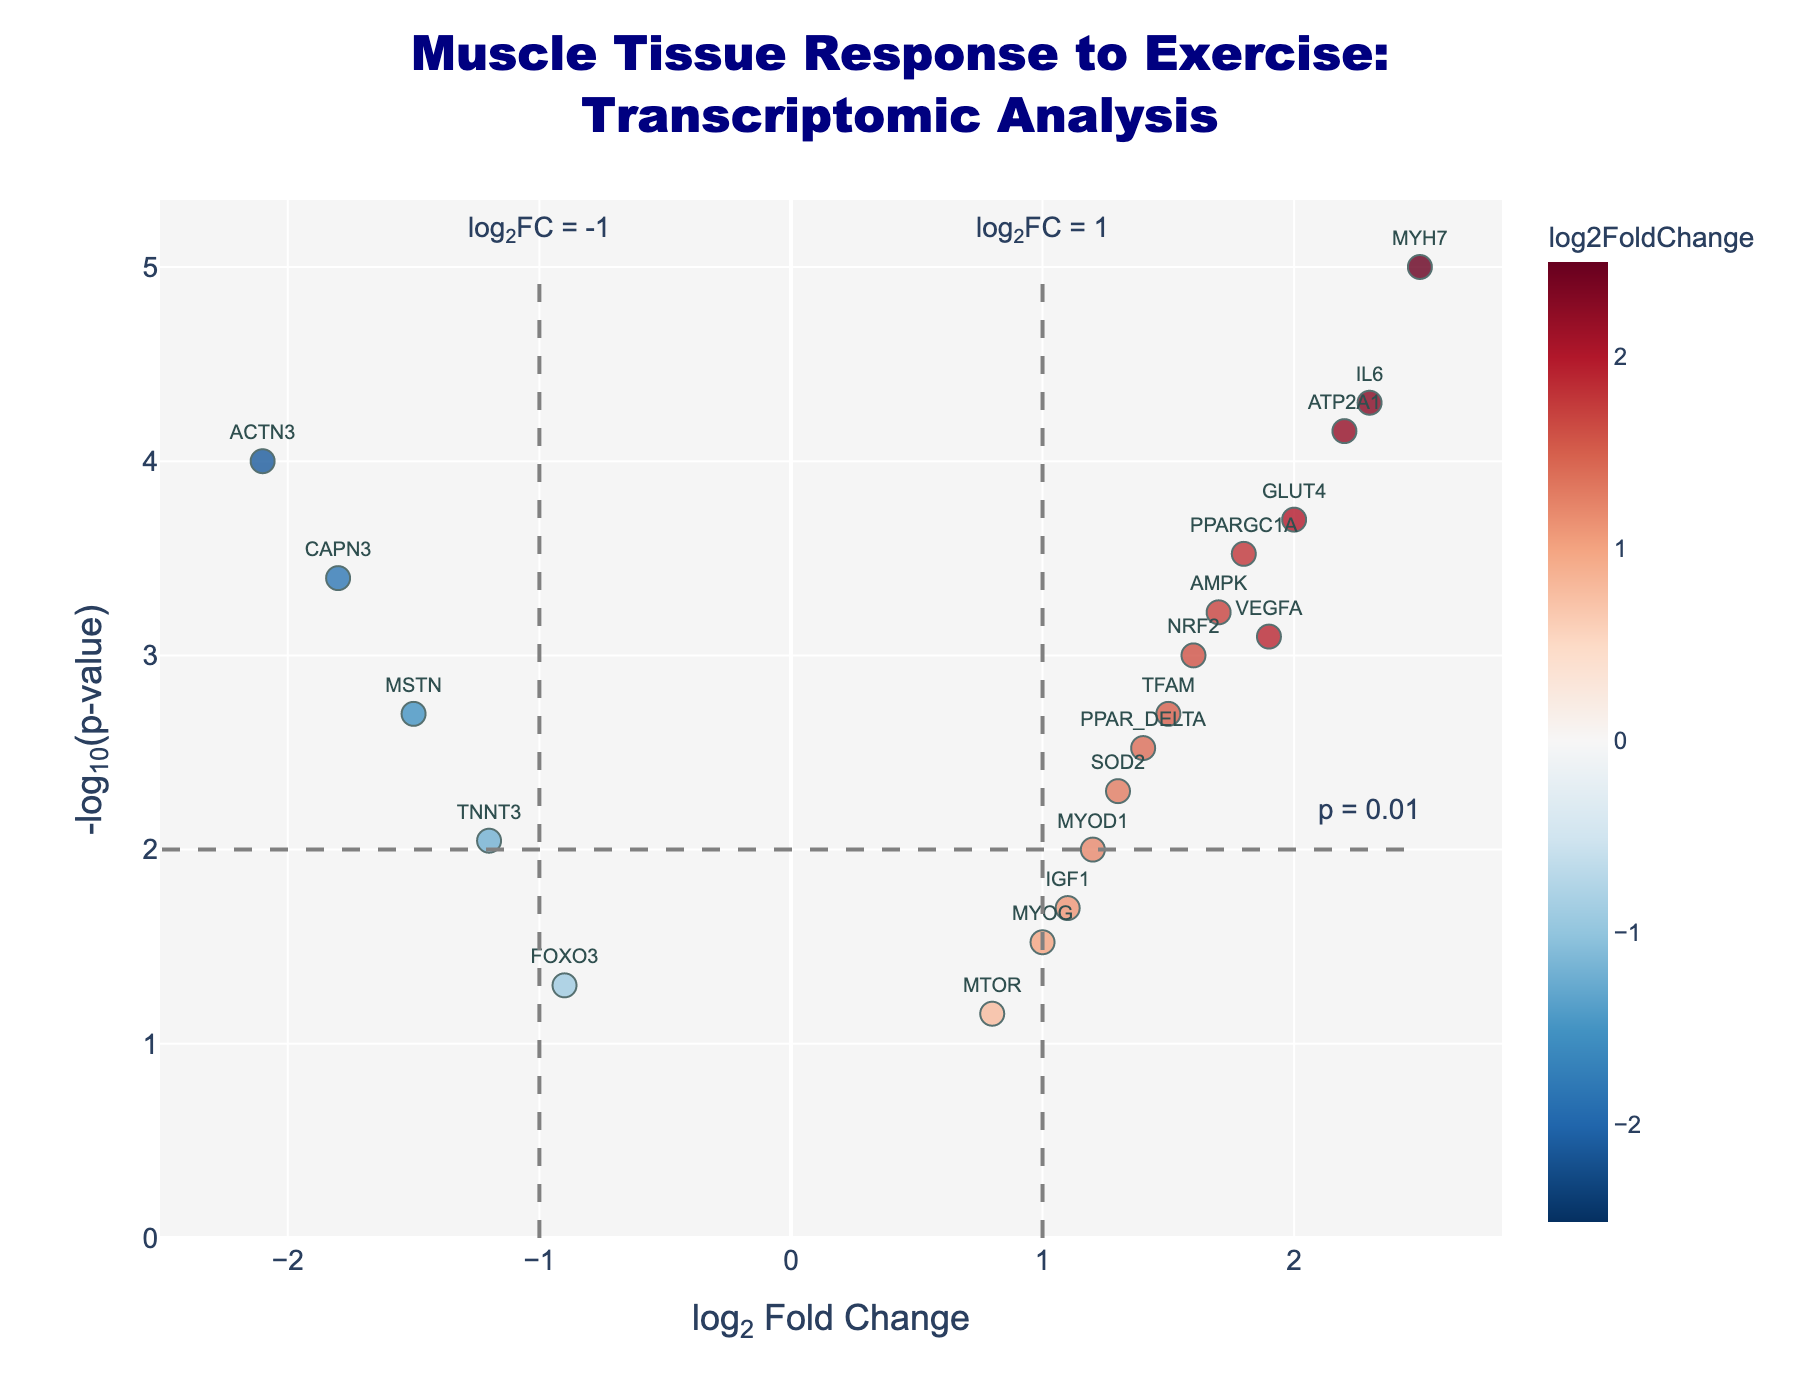What is the title of the plot? The text shown at the top of the plot represents the title.
Answer: Muscle Tissue Response to Exercise: Transcriptomic Analysis Which gene has the highest log2 fold change? Identify the data point with the highest x-axis value. The gene is labeled next to this point.
Answer: MYH7 Which gene is the most significantly differentially expressed? Look for the gene with the highest -log10(p-value) on the y-axis.
Answer: MYH7 What is the color used to indicate genes with negative log2 fold changes? The color of points on the left side of the plot (negative x-axis) is noted.
Answer: Shades of blue How many genes have a p-value less than 0.001? Count the points above the -log10(p-value) of 3 line (since -log10(0.001) = 3).
Answer: 8 Among the genes VEGFA and NRF2, which has a higher -log10(p-value)? Compare the y-axis values of these two labeled points.
Answer: VEGFA What does the dashed vertical line at log2 fold change = 1 indicate? The annotation next to this line indicates the threshold for significant log2 fold change values.
Answer: log2FC = 1 How many genes have a log2 fold change greater than 1 and a p-value less than 0.01? Count the points to the right of the vertical line at x=1 and above the horizontal line at y=-2.
Answer: 5 Which gene is closest to the threshold line for significance with a log2 fold change > 0 and a p-value ≈ 0.001? Identify the point near the 3 horizontal line with a positive x-axis value.
Answer: NRF2 